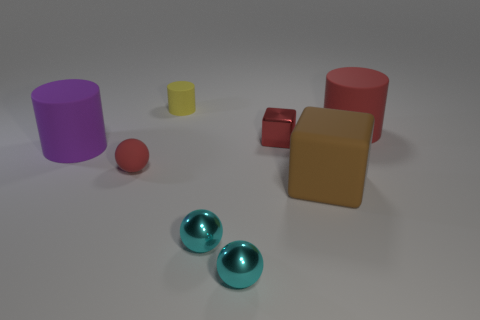There is a rubber cube that is the same size as the red cylinder; what is its color?
Make the answer very short. Brown. Is there a red matte thing that has the same shape as the purple rubber thing?
Offer a terse response. Yes. What is the shape of the purple matte object?
Offer a terse response. Cylinder. Is the number of red things behind the purple rubber cylinder greater than the number of cylinders that are to the left of the large brown thing?
Provide a short and direct response. No. What number of other things are there of the same size as the red sphere?
Provide a succinct answer. 4. What is the material of the thing that is both to the right of the tiny cube and in front of the small rubber ball?
Offer a terse response. Rubber. There is another big thing that is the same shape as the big purple rubber object; what material is it?
Provide a short and direct response. Rubber. What number of red matte spheres are behind the large matte cylinder in front of the red rubber object to the right of the large brown thing?
Make the answer very short. 0. Is there any other thing of the same color as the large cube?
Give a very brief answer. No. What number of things are in front of the matte block and behind the big purple thing?
Your response must be concise. 0. 